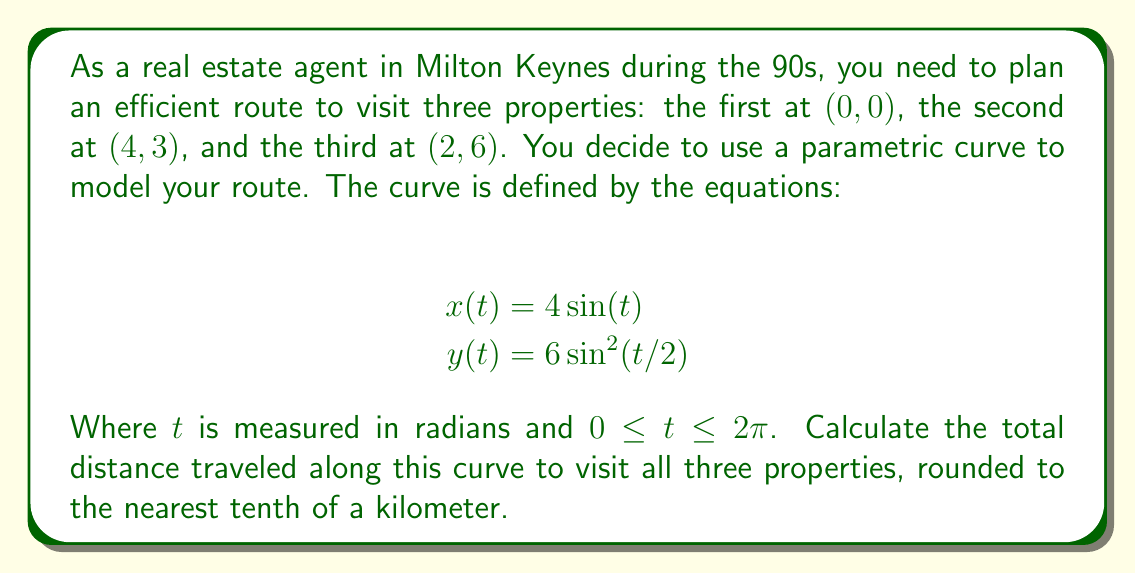Teach me how to tackle this problem. To solve this problem, we'll follow these steps:

1) First, we need to find the $t$ values for each property:

   For $(0, 0)$: $t = 0$ or $t = 2\pi$
   For $(4, 3)$: $x = 4\sin(t) = 4$, so $t = \pi/2$
   For $(2, 6)$: $y = 6\sin^2(t/2) = 6$, so $t = \pi$

2) Now, we need to calculate the arc length between these points. The formula for arc length in parametric equations is:

   $$L = \int_{a}^{b} \sqrt{\left(\frac{dx}{dt}\right)^2 + \left(\frac{dy}{dt}\right)^2} dt$$

3) Let's calculate the derivatives:

   $$\frac{dx}{dt} = 4\cos(t)$$
   $$\frac{dy}{dt} = 6\sin(t/2)\cos(t/2) = 3\sin(t)$$

4) Substituting into the arc length formula:

   $$L = \int_{0}^{\pi} \sqrt{(4\cos(t))^2 + (3\sin(t))^2} dt$$

5) This integral doesn't have an elementary antiderivative, so we'll need to use numerical integration. Using a computer algebra system or numerical integration tool, we get:

   $$L \approx 7.64$$

6) Therefore, the total distance traveled is approximately 7.6 kilometers (rounded to the nearest tenth).
Answer: The total distance traveled along the parametric curve to visit all three properties is approximately 7.6 kilometers. 